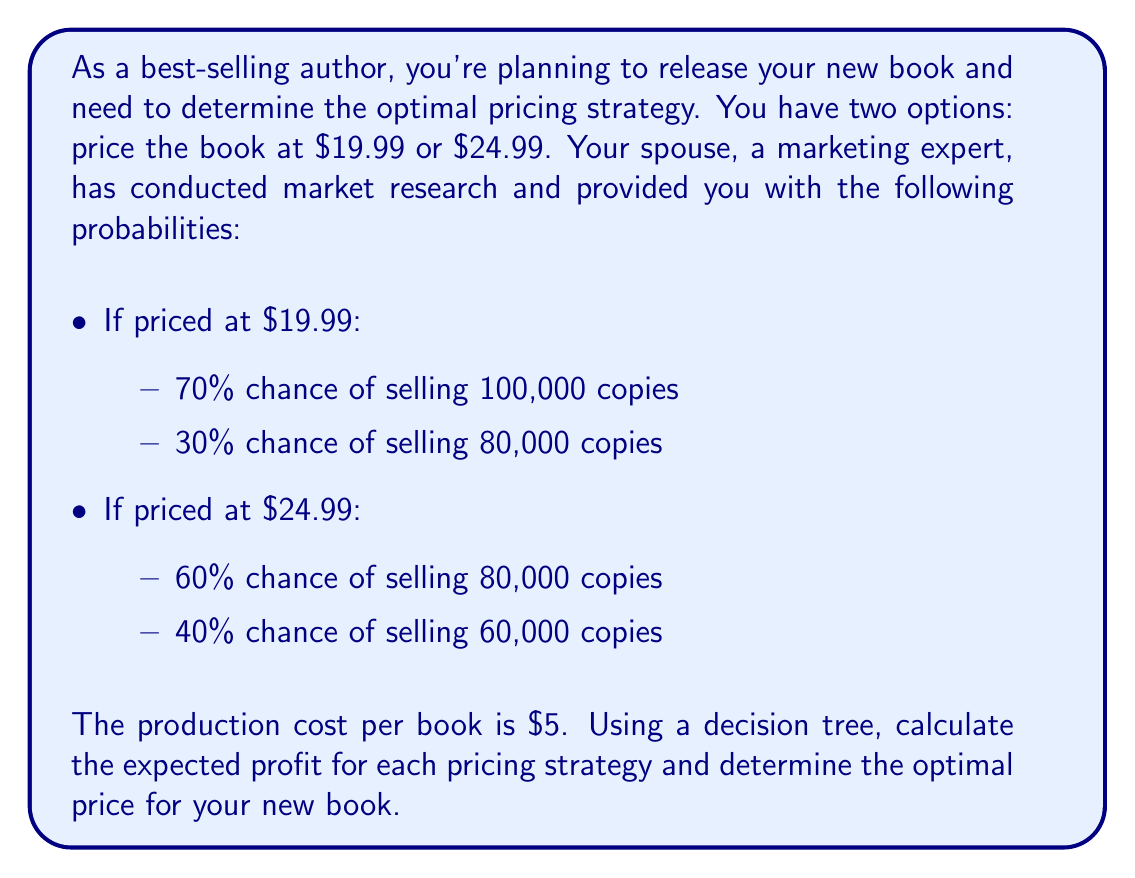Can you answer this question? To solve this problem, we'll construct a decision tree and calculate the expected profit for each pricing strategy.

1. Let's start with the $19.99 pricing strategy:

   a) For 100,000 copies sold:
      Profit = (Price - Cost) × Units
      $$ \text{Profit}_1 = ($19.99 - $5) \times 100,000 = $1,499,000 $$

   b) For 80,000 copies sold:
      $$ \text{Profit}_2 = ($19.99 - $5) \times 80,000 = $1,199,200 $$

   c) Expected profit for $19.99 pricing:
      $$ E(\text{Profit}_{19.99}) = 0.7 \times $1,499,000 + 0.3 \times $1,199,200 = $1,409,760 $$

2. Now for the $24.99 pricing strategy:

   a) For 80,000 copies sold:
      $$ \text{Profit}_3 = ($24.99 - $5) \times 80,000 = $1,599,200 $$

   b) For 60,000 copies sold:
      $$ \text{Profit}_4 = ($24.99 - $5) \times 60,000 = $1,199,400 $$

   c) Expected profit for $24.99 pricing:
      $$ E(\text{Profit}_{24.99}) = 0.6 \times $1,599,200 + 0.4 \times $1,199,400 = $1,439,560 $$

3. Compare the expected profits:
   $E(\text{Profit}_{24.99}) = $1,439,560 > E(\text{Profit}_{19.99}) = $1,409,760$

Therefore, the optimal pricing strategy is to price the book at $24.99, as it yields a higher expected profit.

Here's a visual representation of the decision tree:

[asy]
import geometry;

pair A = (0,0);
pair B1 = (100,50);
pair B2 = (100,-50);
pair C1 = (200,75);
pair C2 = (200,25);
pair C3 = (200,-25);
pair C4 = (200,-75);

draw(A--B1--C1);
draw(A--B1--C2);
draw(A--B2--C3);
draw(A--B2--C4);

label("$19.99", (A+B1)/2, N);
label("$24.99", (A+B2)/2, S);
label("0.7", (B1+C1)/2, N);
label("0.3", (B1+C2)/2, S);
label("0.6", (B2+C3)/2, N);
label("0.4", (B2+C4)/2, S);
label("$1,499,000", C1, E);
label("$1,199,200", C2, E);
label("$1,599,200", C3, E);
label("$1,199,400", C4, E);

dot(A);
dot(B1);
dot(B2);
dot(C1);
dot(C2);
dot(C3);
dot(C4);
[/asy]
Answer: The optimal pricing strategy is to price the book at $24.99, which yields an expected profit of $1,439,560. 